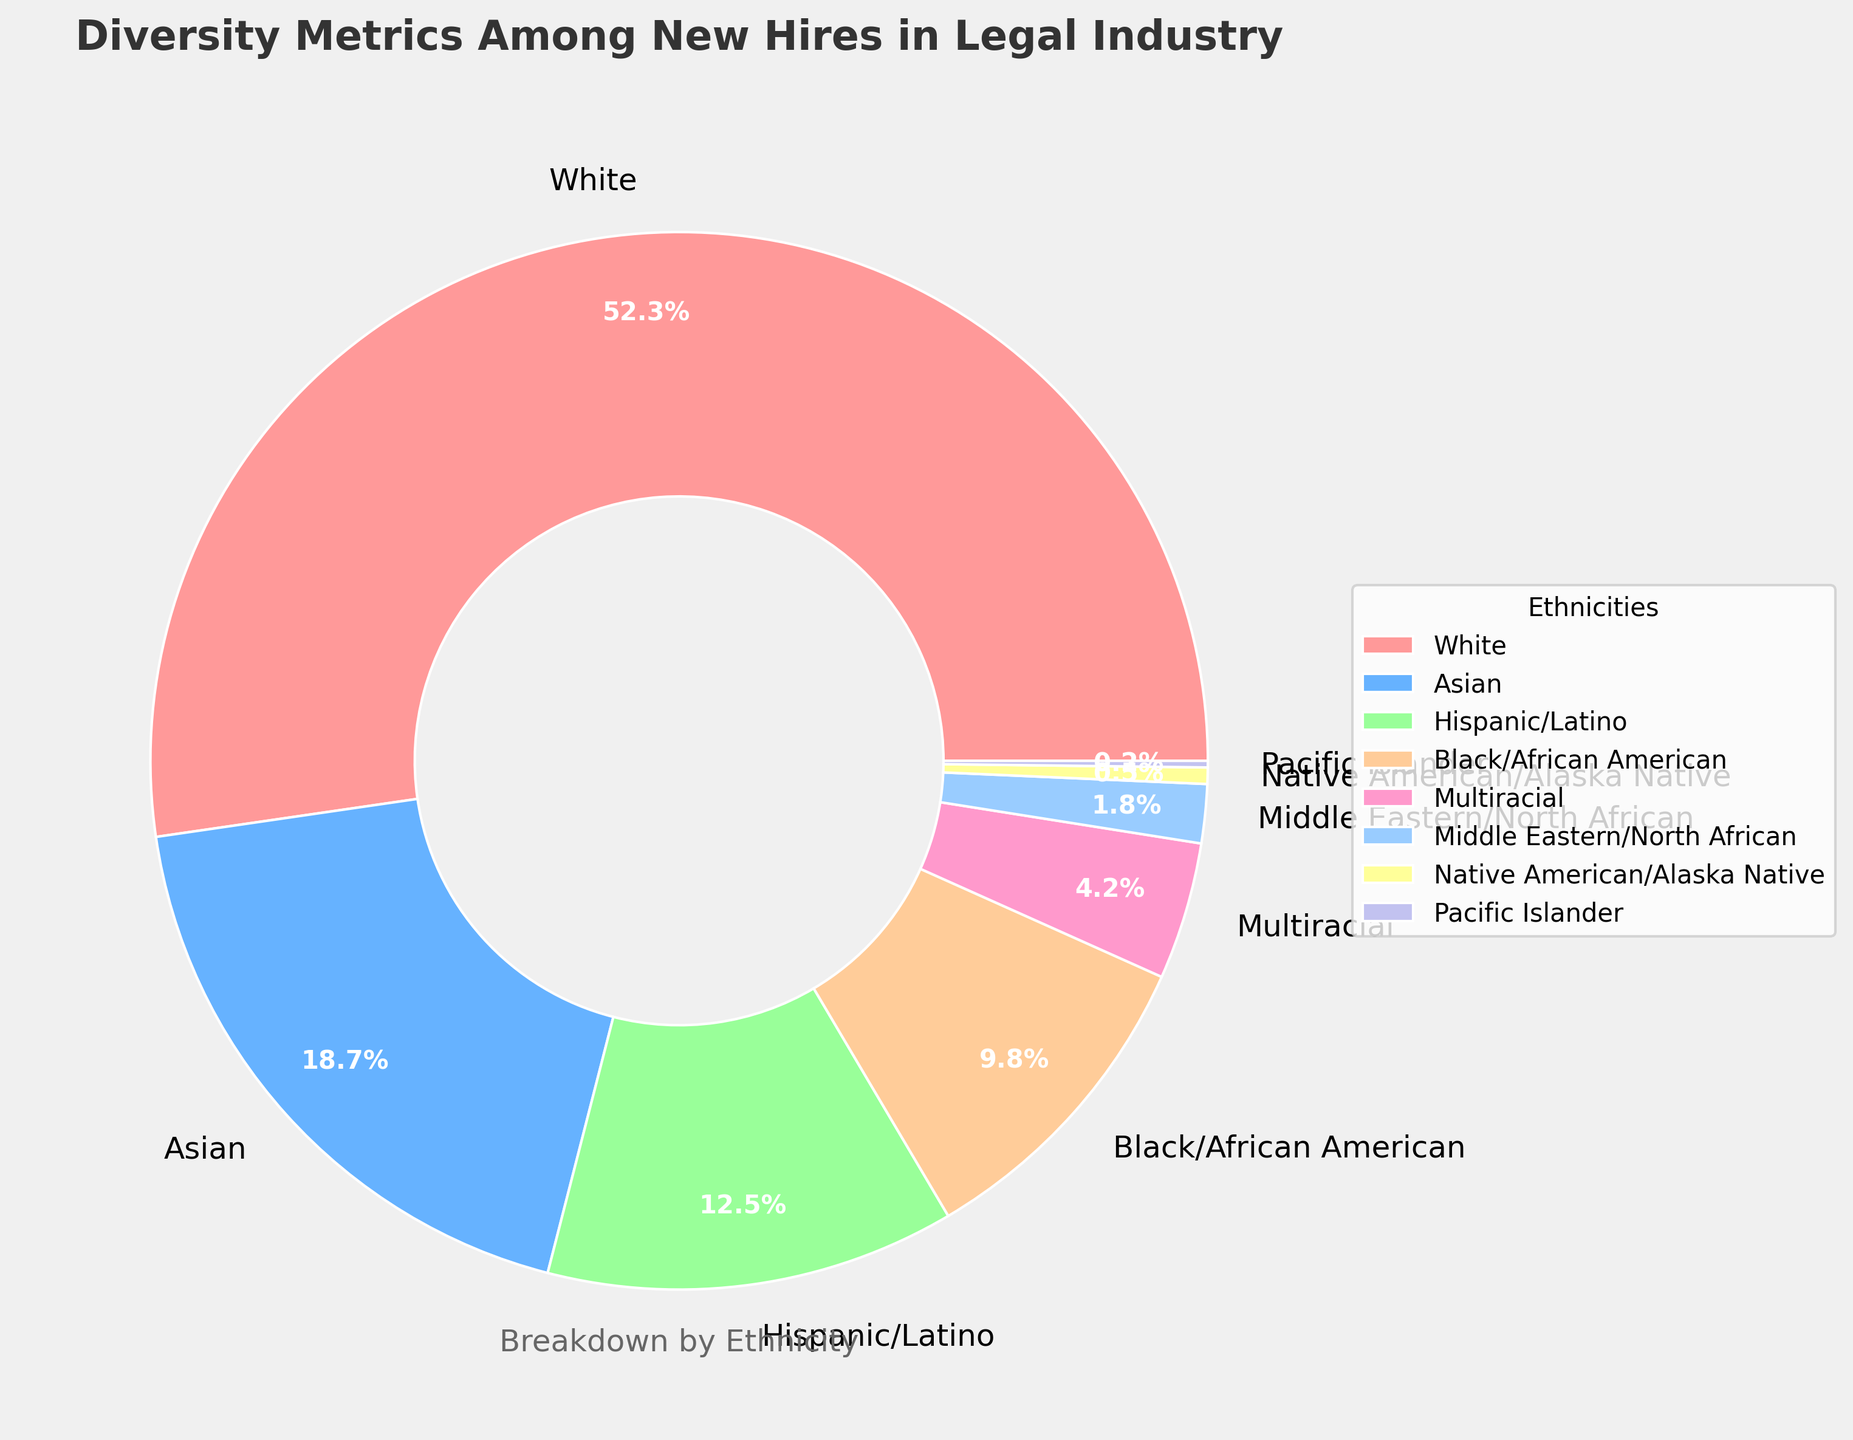what percentage of new hires are either Hispanic/Latino or Black/African American? To find the percentage of new hires that are either Hispanic/Latino or Black/African American, sum the individual percentages of these two groups: 12.5% (Hispanic/Latino) + 9.8% (Black/African American) = 22.3%.
Answer: 22.3% Which group has the lowest representation among new hires? The group with the lowest percentage in the pie chart represents the lowest representation. According to the data, the Pacific Islander group has the lowest percentage at 0.2%.
Answer: Pacific Islander How much greater is the percentage of new hires who are White compared to those who are Asian? To find the difference, subtract the percentage of Asian new hires from the percentage of White new hires: 52.3% (White) - 18.7% (Asian) = 33.6%.
Answer: 33.6% What is the combined percentage of new hires who are from Middle Eastern/North African or Native American/Alaska Native backgrounds? Sum the percentages of Middle Eastern/North African and Native American/Alaska Native: 1.8% + 0.5% = 2.3%.
Answer: 2.3% Are there more new hires who are Multiracial or Asian? To determine this, compare the percentages of Multiracial and Asian new hires. The percentage for Asian is 18.7% and for Multiracial is 4.2%, so there are more Asian new hires.
Answer: Asian What visual features distinguish the wedge representing the Black/African American group? The Black/African American group is displayed with a dark wedge, and it has a label showing the percentage of 9.8%. The percentage value is also displayed inside the wedge in bold, white text.
Answer: Dark wedge, 9.8% If you were to double the percentage of Pacific Islander new hires, what would the new percentage be? Double the percentage of Pacific Islander new hires by multiplying by 2: 0.2% * 2 = 0.4%.
Answer: 0.4% Which groups collectively make up less than 10% of new hires? Sum the percentages of groups that individually have less than 10% until you hit the collective percentage. Adding the percentages for Middle Eastern/North African (1.8%), Native American/Alaska Native (0.5%), and Pacific Islander (0.2%) gives: 1.8% + 0.5% + 0.2% = 2.5%. Include Multiracial (4.2%) to get 6.7%. So, these groups collectively make up less than 10%.
Answer: Middle Eastern/North African, Native American/Alaska Native, Pacific Islander, Multiracial By how much does the percentage of new hires who are White differ from the total percentage of all other groups combined? First, calculate the total percentage of all other groups combined: 100% - 52.3% (White) = 47.7%. The difference between the percentage of new hires who are White and the total percentage of all other groups is 52.3% - 47.7% = 4.6%.
Answer: 4.6% What is the total percentage of new hires who are not White? Subtract the percentage of White new hires from 100% to find the total percentage of non-White new hires: 100% - 52.3% = 47.7%.
Answer: 47.7% 